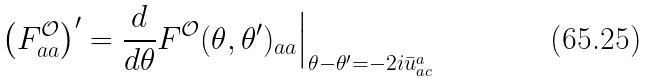Convert formula to latex. <formula><loc_0><loc_0><loc_500><loc_500>\left ( F ^ { \mathcal { O } } _ { a a } \right ) ^ { \prime } = \frac { d } { d \theta } F ^ { \mathcal { O } } ( \theta , \theta ^ { \prime } ) _ { a a } \Big | _ { \theta - \theta ^ { \prime } = - 2 i \bar { u } _ { a c } ^ { a } }</formula> 